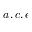<formula> <loc_0><loc_0><loc_500><loc_500>a , c , e</formula> 